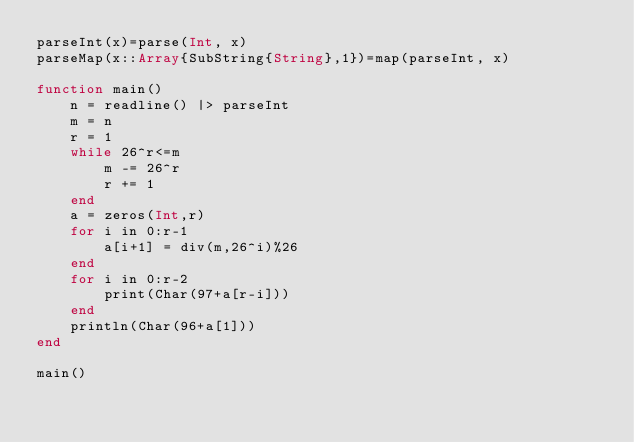Convert code to text. <code><loc_0><loc_0><loc_500><loc_500><_Julia_>parseInt(x)=parse(Int, x)
parseMap(x::Array{SubString{String},1})=map(parseInt, x)

function main()
	n = readline() |> parseInt
	m = n
	r = 1
	while 26^r<=m
		m -= 26^r
		r += 1
	end
	a = zeros(Int,r)
	for i in 0:r-1
		a[i+1] = div(m,26^i)%26
	end
	for i in 0:r-2
		print(Char(97+a[r-i]))
	end
	println(Char(96+a[1]))
end

main()</code> 